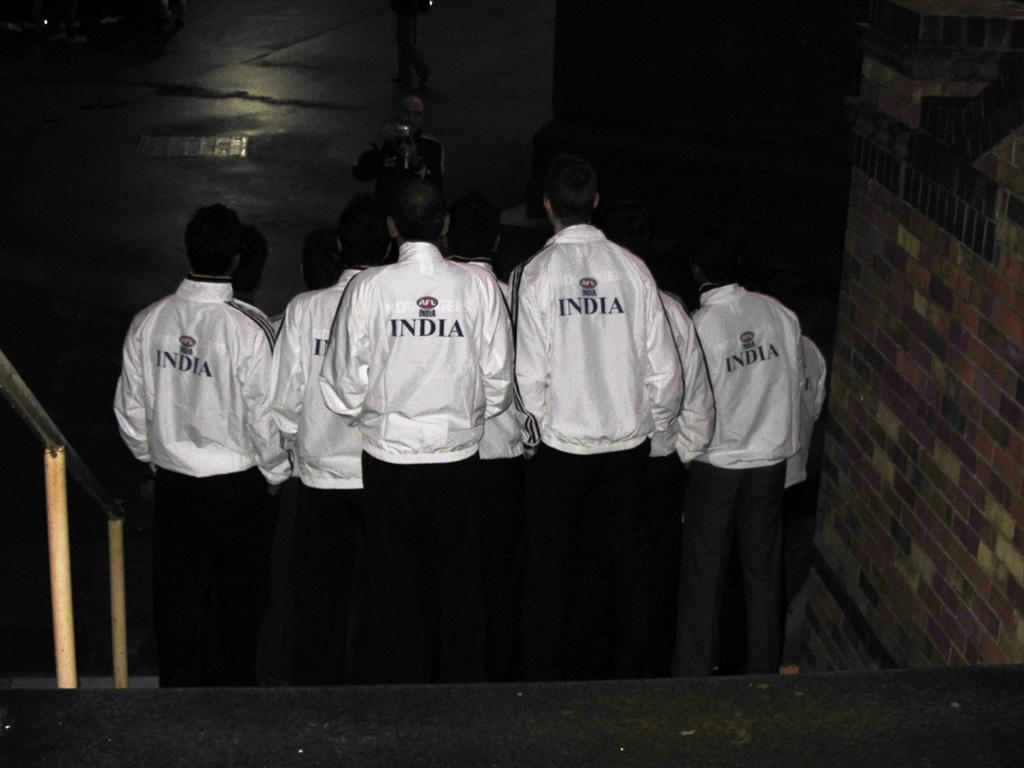Provide a one-sentence caption for the provided image. A group of men with white India sweaters taking a photo together. 